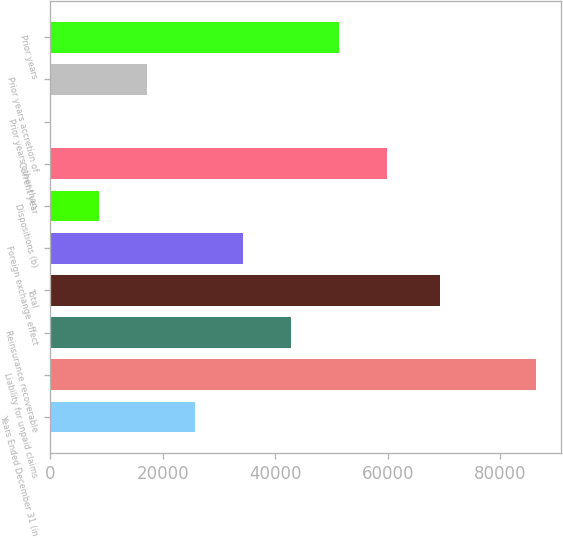Convert chart to OTSL. <chart><loc_0><loc_0><loc_500><loc_500><bar_chart><fcel>Years Ended December 31 (in<fcel>Liability for unpaid claims<fcel>Reinsurance recoverable<fcel>Total<fcel>Foreign exchange effect<fcel>Dispositions (b)<fcel>Current year<fcel>Prior years other than<fcel>Prior years accretion of<fcel>Prior years<nl><fcel>25732.6<fcel>86364.4<fcel>42809<fcel>69288<fcel>34270.8<fcel>8656.2<fcel>59885.4<fcel>118<fcel>17194.4<fcel>51347.2<nl></chart> 